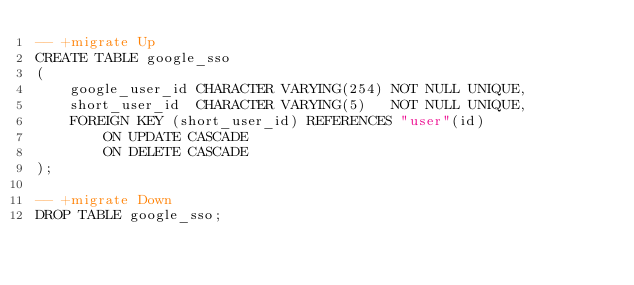<code> <loc_0><loc_0><loc_500><loc_500><_SQL_>-- +migrate Up
CREATE TABLE google_sso
(
    google_user_id CHARACTER VARYING(254) NOT NULL UNIQUE,
    short_user_id  CHARACTER VARYING(5)   NOT NULL UNIQUE,
    FOREIGN KEY (short_user_id) REFERENCES "user"(id)
        ON UPDATE CASCADE
        ON DELETE CASCADE
);

-- +migrate Down
DROP TABLE google_sso;</code> 